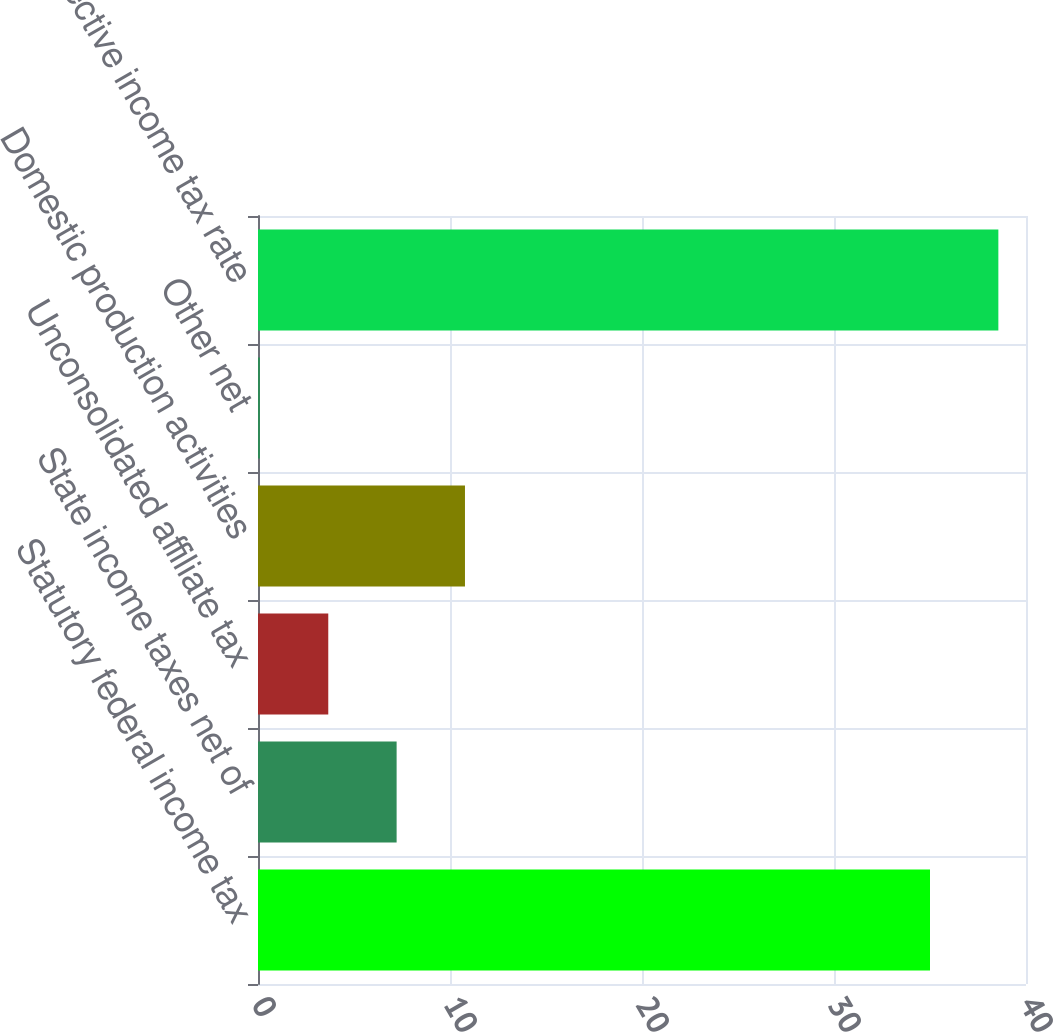Convert chart to OTSL. <chart><loc_0><loc_0><loc_500><loc_500><bar_chart><fcel>Statutory federal income tax<fcel>State income taxes net of<fcel>Unconsolidated affiliate tax<fcel>Domestic production activities<fcel>Other net<fcel>Effective income tax rate<nl><fcel>35<fcel>7.22<fcel>3.66<fcel>10.78<fcel>0.1<fcel>38.56<nl></chart> 